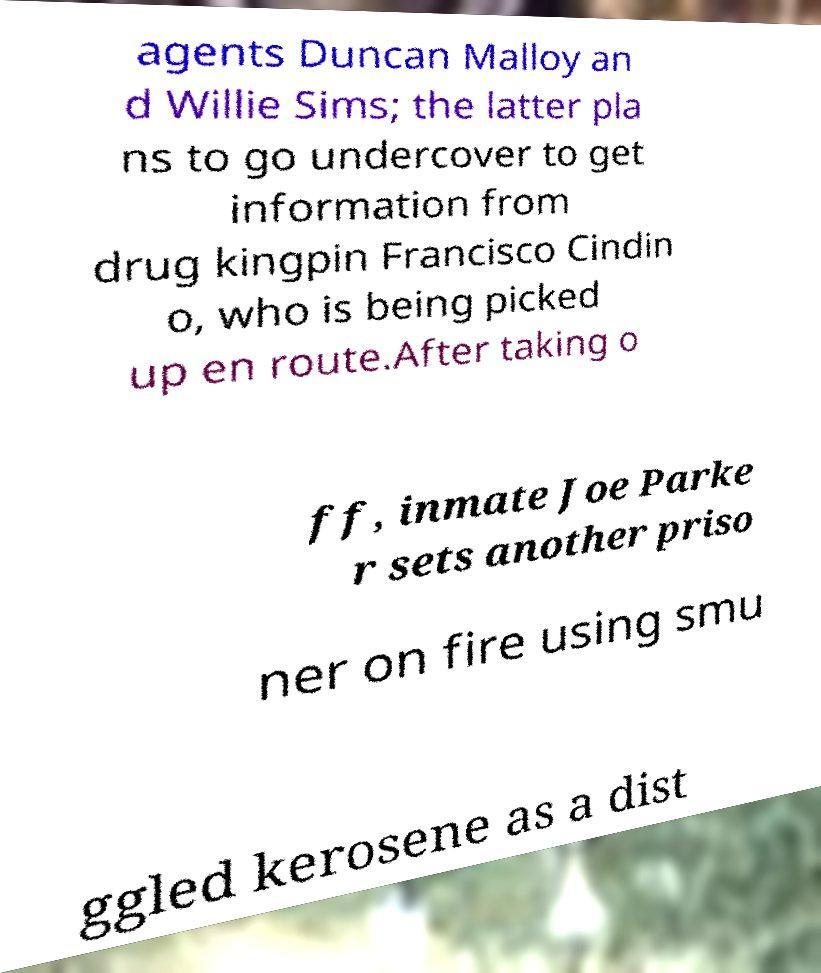There's text embedded in this image that I need extracted. Can you transcribe it verbatim? agents Duncan Malloy an d Willie Sims; the latter pla ns to go undercover to get information from drug kingpin Francisco Cindin o, who is being picked up en route.After taking o ff, inmate Joe Parke r sets another priso ner on fire using smu ggled kerosene as a dist 